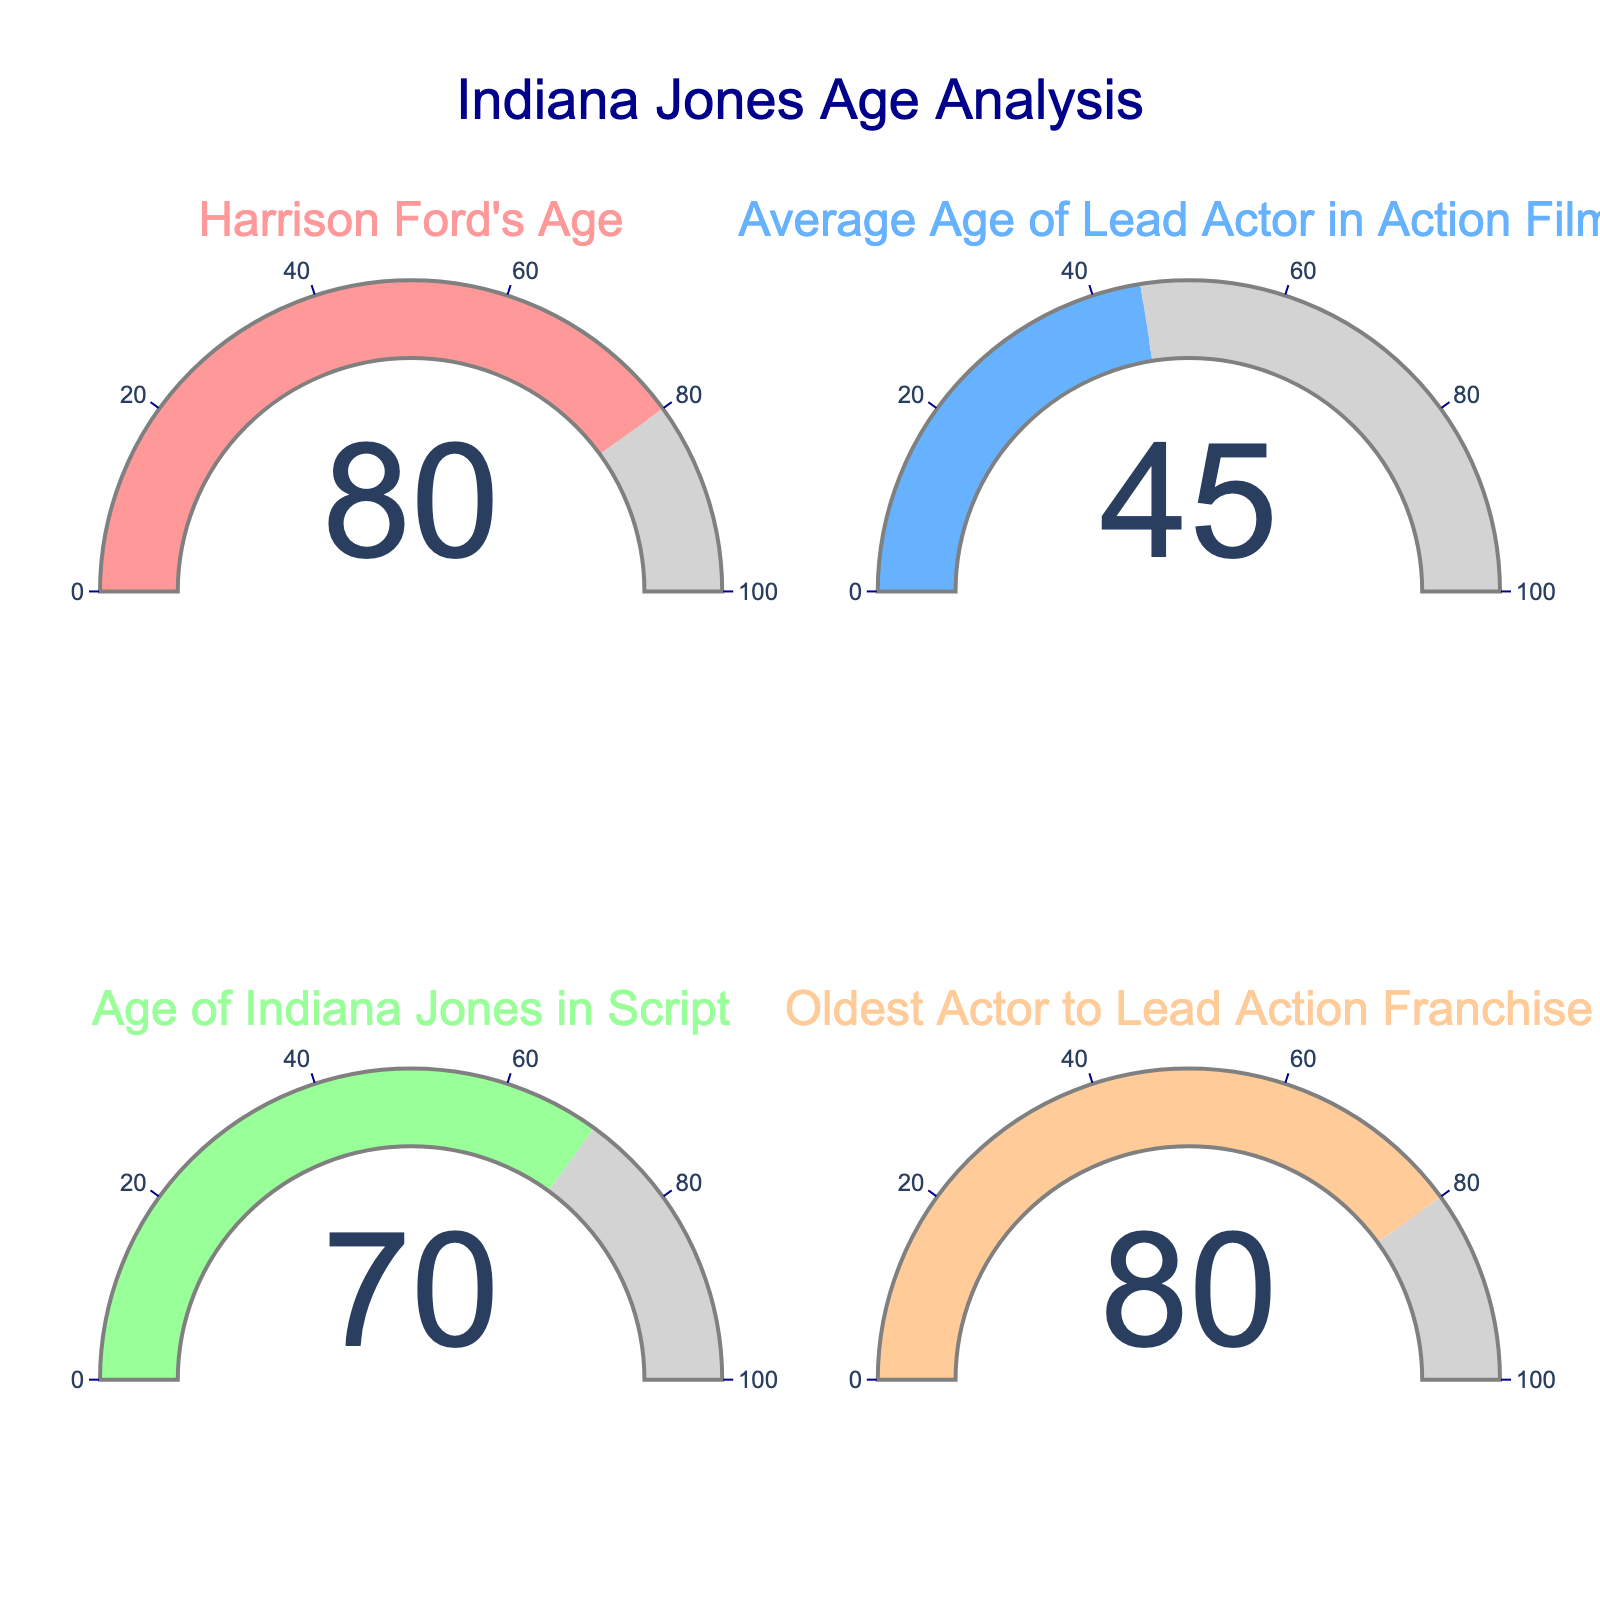What is the age of Harrison Ford during the filming of the most recent Indiana Jones movie? Refer to the gauge titled "Harrison Ford's Age." The gauge shows that Harrison Ford was 80 years old during the filming of the movie.
Answer: 80 What is the average age of lead actors in action films according to the gauge? Look at the gauge titled "Average Age of Lead Actor in Action Films." It indicates that the average age is 45.
Answer: 45 What is the age difference between Harrison Ford and the average lead actor in action films? Subtract the average age of lead actors (45) from Harrison Ford's age (80). The age difference is 80 - 45 = 35 years.
Answer: 35 Which gauge shows the oldest age and what is that age? The gauges include Harrison Ford’s age (80), average lead actor's age (45), Indiana Jones’ age in the script (70), and the oldest actor to lead an action franchise (80). Both Harrison Ford's age and the oldest actor leading an action franchise show the highest value (80).
Answer: 80 Who is older, Harrison Ford or the character Indiana Jones as scripted? Compare the values: Harrison Ford's age is 80, and Indiana Jones in the script is 70. Harrison Ford is older.
Answer: Harrison Ford How much younger is Indiana Jones in the script compared to Harrison Ford in the movie? Subtract Indiana Jones' age in the script (70) from Harrison Ford's age (80). The difference is 80 - 70 = 10 years.
Answer: 10 How much older is Harrison Ford compared to the average lead actor in action films? Subtract the average age of lead actors (45) from Harrison Ford's age (80). The difference is 80 - 45 = 35 years.
Answer: 35 Does the age of the oldest actor to lead an action franchise match Harrison Ford's age? Check both gauges for Harrison Ford's age and the oldest actor to lead an action franchise. Both show an age of 80 years, so they match.
Answer: Yes What is the combined age of Harrison Ford and Indiana Jones in the script as shown on the gauges? Add the ages shown on the gauges for Harrison Ford (80) and Indiana Jones in the script (70). The total is 80 + 70 = 150 years.
Answer: 150 Is Harrison Ford's age unprecedented for a lead actor in an action franchise according to the gauges? Compare Harrison Ford's age (80) with the gauge indicating the oldest actor to lead an action franchise (80). Harrison Ford's age is the same, meaning it matches the precedent.
Answer: No 